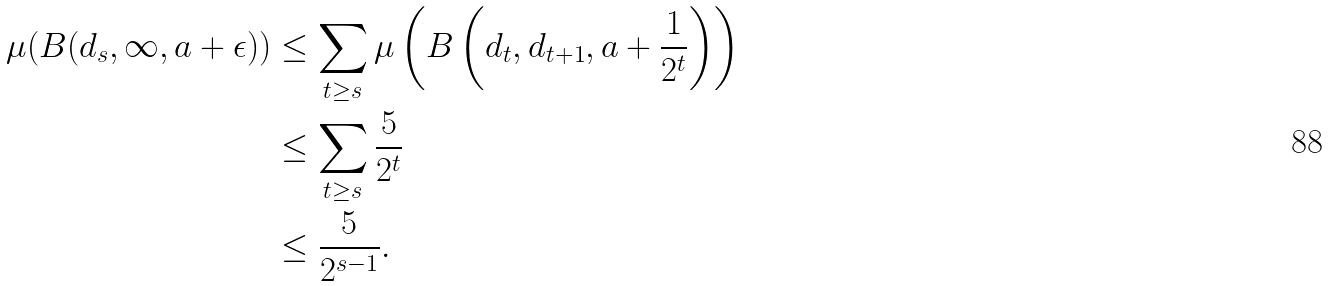<formula> <loc_0><loc_0><loc_500><loc_500>\mu ( B ( d _ { s } , \infty , a + \epsilon ) ) & \leq \sum _ { t \geq s } \mu \left ( B \left ( d _ { t } , d _ { t + 1 } , a + \frac { 1 } { 2 ^ { t } } \right ) \right ) \\ & \leq \sum _ { t \geq s } \frac { 5 } { 2 ^ { t } } \\ & \leq \frac { 5 } { 2 ^ { s - 1 } } .</formula> 